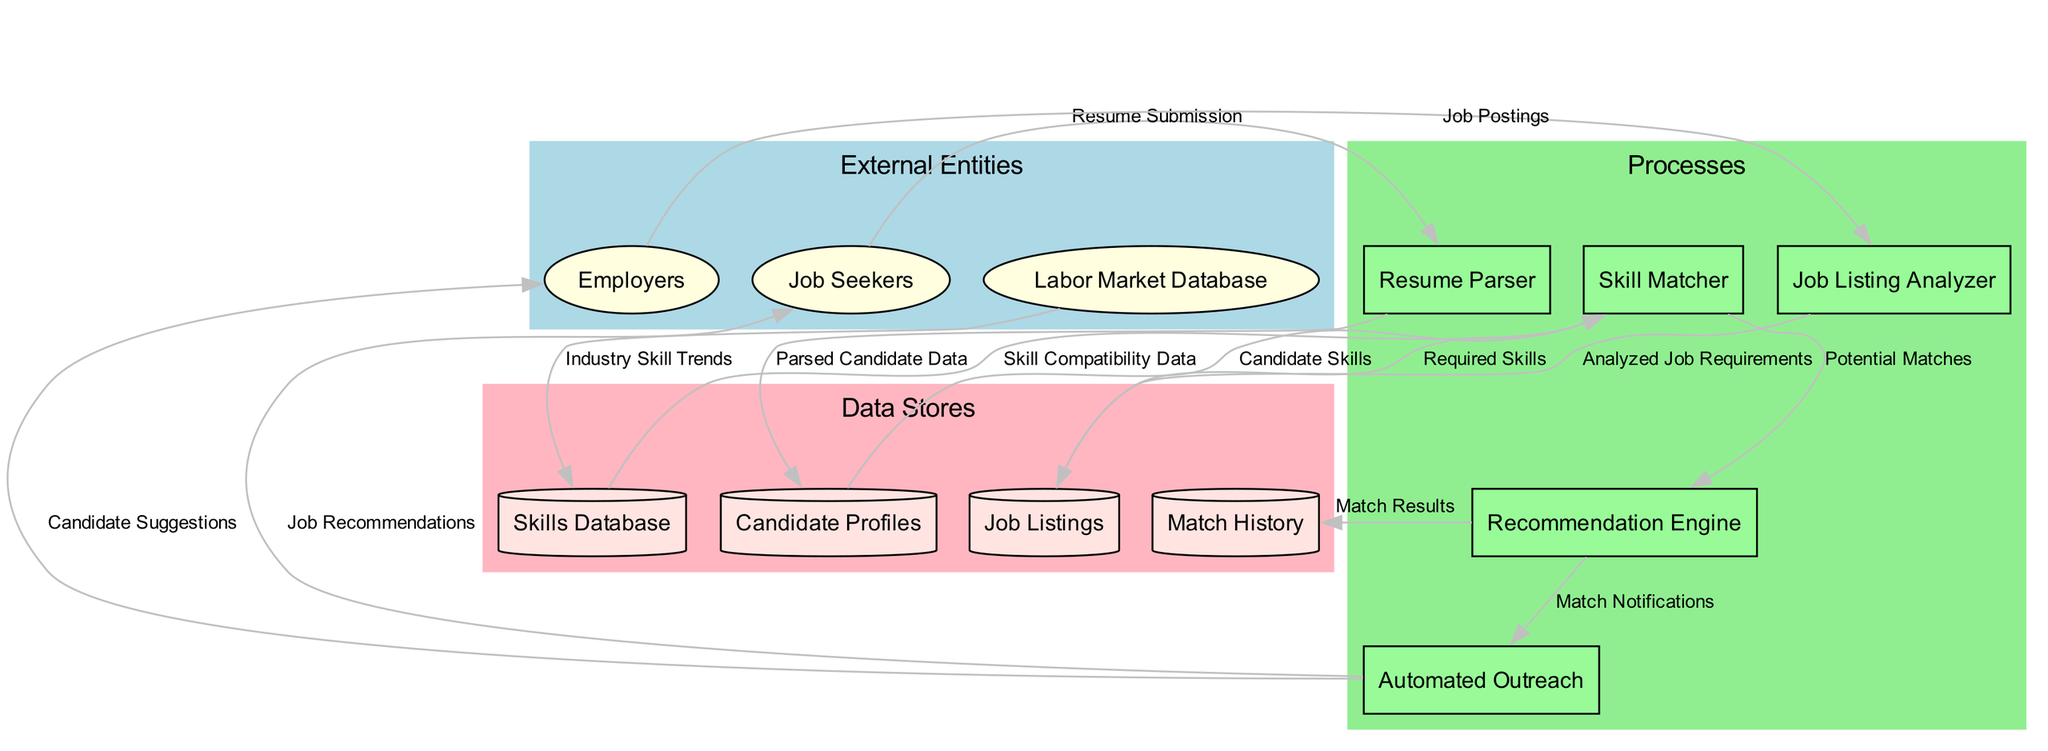What is the number of external entities in the diagram? The diagram lists three external entities: Job Seekers, Employers, and Labor Market Database. Counting these entities gives a total of three.
Answer: 3 What data flows from Job Seekers to the Resume Parser? The data flow from Job Seekers to the Resume Parser is labeled "Resume Submission." This indicates that candidates submit their resumes to be parsed.
Answer: Resume Submission Which process receives data from the Job Listing Analyzer? The process that receives data from the Job Listing Analyzer is Job Listings. The flow labeled "Analyzed Job Requirements" indicates this relationship.
Answer: Job Listings How many processes are depicted in the diagram? There are five processes represented in the diagram: Resume Parser, Job Listing Analyzer, Skill Matcher, Recommendation Engine, and Automated Outreach. Counting each process results in five.
Answer: 5 What is the role of the Skill Matcher in the diagram? The Skill Matcher takes input from Candidate Profiles and Job Listings to determine potential matches between job seekers and job openings based on skill compatibility. This indicates that it plays a critical role in the matching process.
Answer: Matchmaking What label describes the data flowing from the Skills Database to the Skill Matcher? The label for the data flow from the Skills Database to the Skill Matcher is "Skill Compatibility Data." This signifies that the Matcher uses this data to find compatible skills for job candidates and listings.
Answer: Skill Compatibility Data Which external entity receives job recommendations from Automated Outreach? Job Seekers are the external entity that receives job recommendations from Automated Outreach, as indicated by the labeled data flow "Job Recommendations."
Answer: Job Seekers In total, how many data stores are involved in the diagram? The diagram involves four data stores: Candidate Profiles, Job Listings, Skills Database, and Match History. Adding these up yields a total of four data stores present in the system.
Answer: 4 What happens to the match results produced by the Recommendation Engine? The match results generated by the Recommendation Engine are stored in the Match History and are also used to send out Match Notifications through Automated Outreach, indicating that two functions are performed with these results.
Answer: Stored and notified 